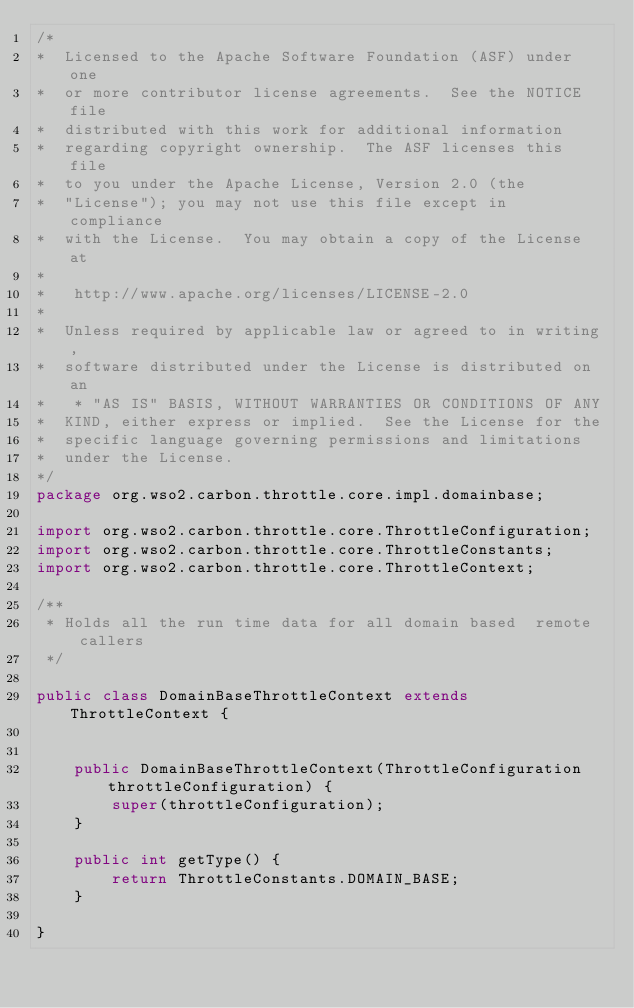<code> <loc_0><loc_0><loc_500><loc_500><_Java_>/*
*  Licensed to the Apache Software Foundation (ASF) under one
*  or more contributor license agreements.  See the NOTICE file
*  distributed with this work for additional information
*  regarding copyright ownership.  The ASF licenses this file
*  to you under the Apache License, Version 2.0 (the
*  "License"); you may not use this file except in compliance
*  with the License.  You may obtain a copy of the License at
*
*   http://www.apache.org/licenses/LICENSE-2.0
*
*  Unless required by applicable law or agreed to in writing,
*  software distributed under the License is distributed on an
*   * "AS IS" BASIS, WITHOUT WARRANTIES OR CONDITIONS OF ANY
*  KIND, either express or implied.  See the License for the
*  specific language governing permissions and limitations
*  under the License.
*/
package org.wso2.carbon.throttle.core.impl.domainbase;

import org.wso2.carbon.throttle.core.ThrottleConfiguration;
import org.wso2.carbon.throttle.core.ThrottleConstants;
import org.wso2.carbon.throttle.core.ThrottleContext;

/**
 * Holds all the run time data for all domain based  remote callers
 */

public class DomainBaseThrottleContext extends ThrottleContext {


    public DomainBaseThrottleContext(ThrottleConfiguration throttleConfiguration) {
        super(throttleConfiguration);
    }

    public int getType() {
        return ThrottleConstants.DOMAIN_BASE;
    }

}
</code> 